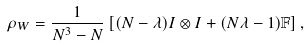<formula> <loc_0><loc_0><loc_500><loc_500>\rho _ { W } = \frac { 1 } { N ^ { 3 } - N } \left [ ( N - \lambda ) I \otimes I + ( N \lambda - 1 ) { \mathbb { F } } \right ] ,</formula> 